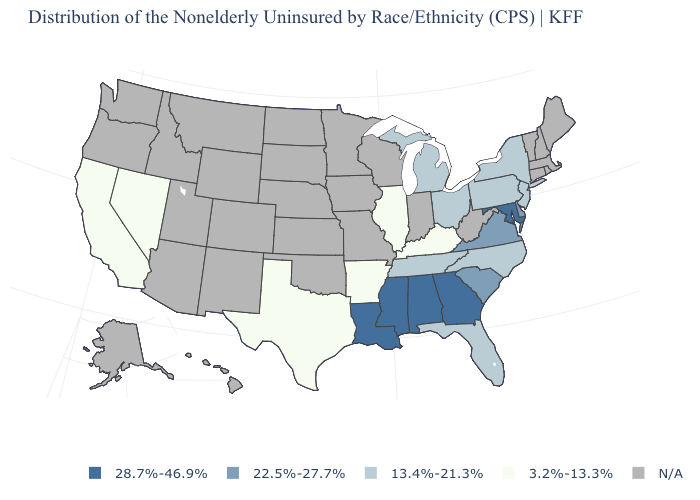What is the lowest value in states that border Arizona?
Short answer required. 3.2%-13.3%. What is the value of Tennessee?
Concise answer only. 13.4%-21.3%. What is the value of Connecticut?
Answer briefly. N/A. Name the states that have a value in the range 3.2%-13.3%?
Quick response, please. Arkansas, California, Illinois, Kentucky, Nevada, Texas. Does Kentucky have the lowest value in the South?
Write a very short answer. Yes. Does the first symbol in the legend represent the smallest category?
Concise answer only. No. What is the highest value in the USA?
Short answer required. 28.7%-46.9%. Does the first symbol in the legend represent the smallest category?
Concise answer only. No. Is the legend a continuous bar?
Be succinct. No. What is the value of Idaho?
Write a very short answer. N/A. Does the map have missing data?
Short answer required. Yes. What is the lowest value in the USA?
Be succinct. 3.2%-13.3%. Does the first symbol in the legend represent the smallest category?
Quick response, please. No. Among the states that border Pennsylvania , does Maryland have the highest value?
Quick response, please. Yes. 